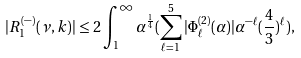<formula> <loc_0><loc_0><loc_500><loc_500>| R ^ { ( - ) } _ { 1 } ( \nu , k ) | \leq 2 \int _ { 1 } ^ { \infty } \alpha ^ { \frac { 1 } { 4 } } ( \sum _ { \ell = 1 } ^ { 5 } | \Phi ^ { ( 2 ) } _ { \ell } ( \alpha ) | \alpha ^ { - \ell } ( \frac { 4 } { 3 } ) ^ { \ell } ) ,</formula> 